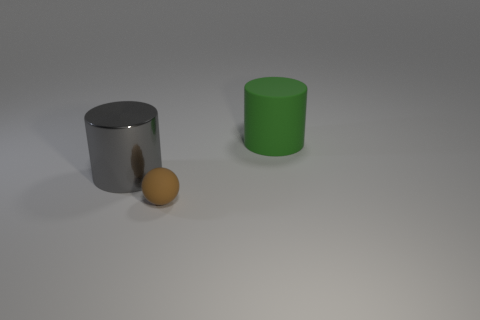Add 2 brown metal blocks. How many objects exist? 5 Subtract all cylinders. How many objects are left? 1 Subtract 0 gray balls. How many objects are left? 3 Subtract all green rubber things. Subtract all gray cylinders. How many objects are left? 1 Add 1 large gray metallic objects. How many large gray metallic objects are left? 2 Add 3 big red things. How many big red things exist? 3 